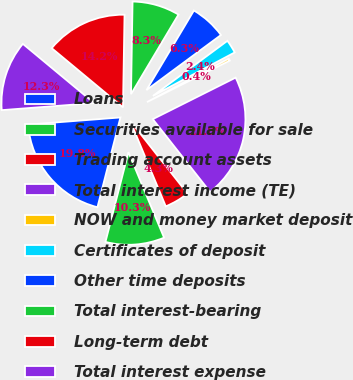Convert chart to OTSL. <chart><loc_0><loc_0><loc_500><loc_500><pie_chart><fcel>Loans<fcel>Securities available for sale<fcel>Trading account assets<fcel>Total interest income (TE)<fcel>NOW and money market deposit<fcel>Certificates of deposit<fcel>Other time deposits<fcel>Total interest-bearing<fcel>Long-term debt<fcel>Total interest expense<nl><fcel>19.79%<fcel>10.27%<fcel>4.34%<fcel>21.77%<fcel>0.38%<fcel>2.36%<fcel>6.31%<fcel>8.29%<fcel>14.23%<fcel>12.25%<nl></chart> 